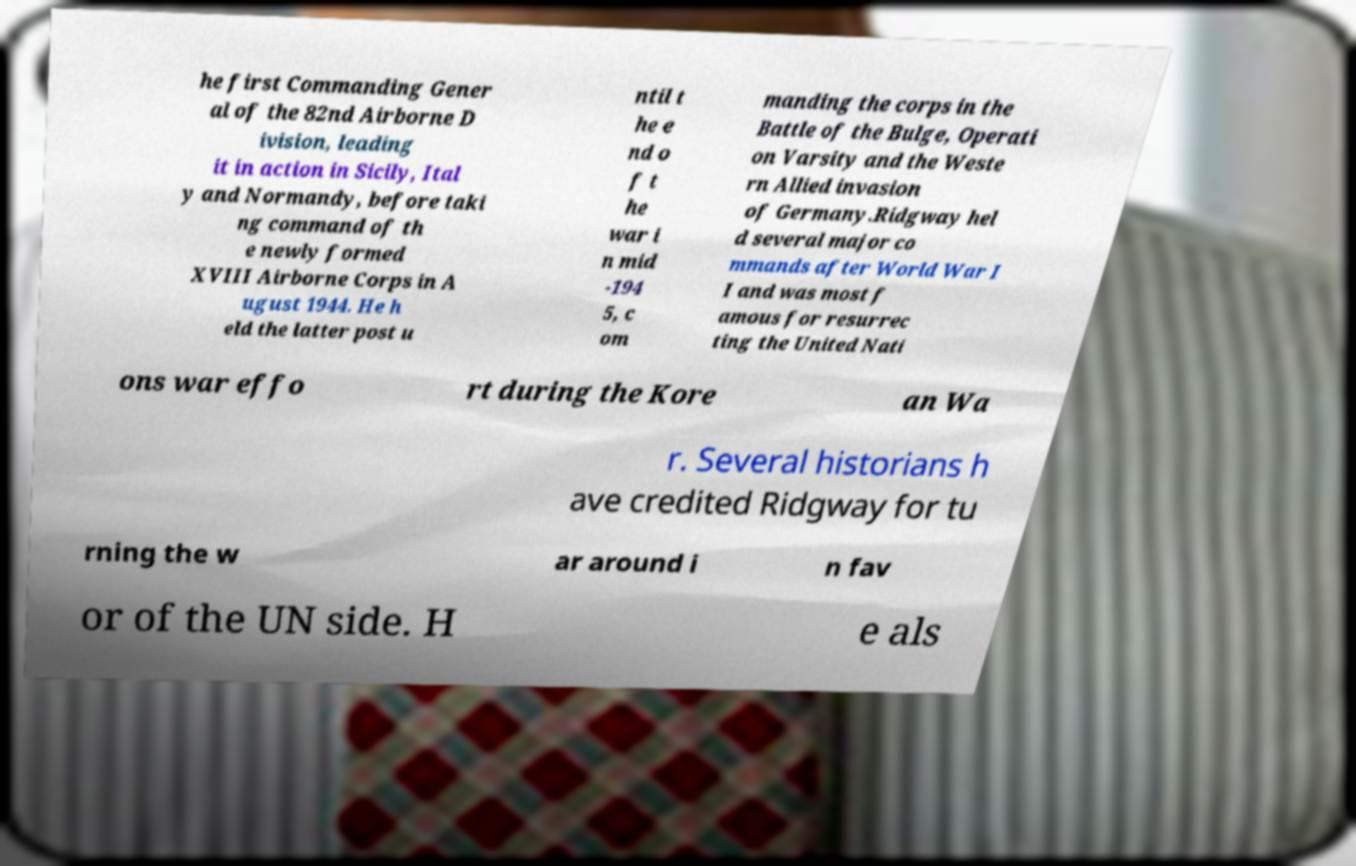Please read and relay the text visible in this image. What does it say? he first Commanding Gener al of the 82nd Airborne D ivision, leading it in action in Sicily, Ital y and Normandy, before taki ng command of th e newly formed XVIII Airborne Corps in A ugust 1944. He h eld the latter post u ntil t he e nd o f t he war i n mid -194 5, c om manding the corps in the Battle of the Bulge, Operati on Varsity and the Weste rn Allied invasion of Germany.Ridgway hel d several major co mmands after World War I I and was most f amous for resurrec ting the United Nati ons war effo rt during the Kore an Wa r. Several historians h ave credited Ridgway for tu rning the w ar around i n fav or of the UN side. H e als 